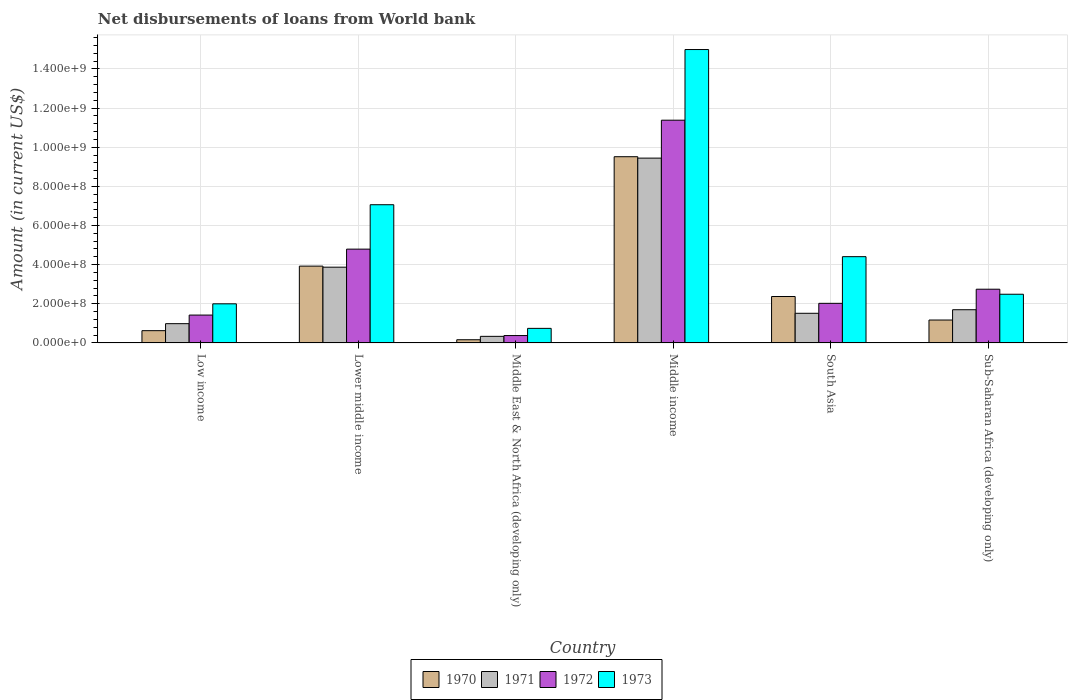How many different coloured bars are there?
Your answer should be very brief. 4. How many bars are there on the 1st tick from the left?
Ensure brevity in your answer.  4. How many bars are there on the 4th tick from the right?
Make the answer very short. 4. In how many cases, is the number of bars for a given country not equal to the number of legend labels?
Provide a short and direct response. 0. What is the amount of loan disbursed from World Bank in 1971 in Middle East & North Africa (developing only)?
Your answer should be very brief. 3.37e+07. Across all countries, what is the maximum amount of loan disbursed from World Bank in 1971?
Your answer should be very brief. 9.44e+08. Across all countries, what is the minimum amount of loan disbursed from World Bank in 1970?
Offer a terse response. 1.64e+07. In which country was the amount of loan disbursed from World Bank in 1970 minimum?
Your answer should be compact. Middle East & North Africa (developing only). What is the total amount of loan disbursed from World Bank in 1972 in the graph?
Provide a succinct answer. 2.27e+09. What is the difference between the amount of loan disbursed from World Bank in 1971 in Middle East & North Africa (developing only) and that in Sub-Saharan Africa (developing only)?
Your answer should be compact. -1.36e+08. What is the difference between the amount of loan disbursed from World Bank in 1970 in Lower middle income and the amount of loan disbursed from World Bank in 1971 in Middle income?
Keep it short and to the point. -5.52e+08. What is the average amount of loan disbursed from World Bank in 1973 per country?
Provide a succinct answer. 5.28e+08. What is the difference between the amount of loan disbursed from World Bank of/in 1970 and amount of loan disbursed from World Bank of/in 1972 in Sub-Saharan Africa (developing only)?
Provide a short and direct response. -1.57e+08. What is the ratio of the amount of loan disbursed from World Bank in 1971 in Low income to that in Middle East & North Africa (developing only)?
Ensure brevity in your answer.  2.92. Is the amount of loan disbursed from World Bank in 1973 in Lower middle income less than that in South Asia?
Your answer should be very brief. No. What is the difference between the highest and the second highest amount of loan disbursed from World Bank in 1972?
Provide a short and direct response. 8.63e+08. What is the difference between the highest and the lowest amount of loan disbursed from World Bank in 1971?
Make the answer very short. 9.10e+08. In how many countries, is the amount of loan disbursed from World Bank in 1971 greater than the average amount of loan disbursed from World Bank in 1971 taken over all countries?
Offer a terse response. 2. Is the sum of the amount of loan disbursed from World Bank in 1970 in Lower middle income and South Asia greater than the maximum amount of loan disbursed from World Bank in 1972 across all countries?
Your response must be concise. No. Is it the case that in every country, the sum of the amount of loan disbursed from World Bank in 1972 and amount of loan disbursed from World Bank in 1971 is greater than the amount of loan disbursed from World Bank in 1973?
Provide a short and direct response. No. Are all the bars in the graph horizontal?
Your response must be concise. No. What is the difference between two consecutive major ticks on the Y-axis?
Your response must be concise. 2.00e+08. Are the values on the major ticks of Y-axis written in scientific E-notation?
Make the answer very short. Yes. How many legend labels are there?
Your response must be concise. 4. What is the title of the graph?
Ensure brevity in your answer.  Net disbursements of loans from World bank. What is the label or title of the X-axis?
Your answer should be compact. Country. What is the Amount (in current US$) in 1970 in Low income?
Offer a terse response. 6.27e+07. What is the Amount (in current US$) of 1971 in Low income?
Offer a terse response. 9.85e+07. What is the Amount (in current US$) of 1972 in Low income?
Provide a succinct answer. 1.42e+08. What is the Amount (in current US$) of 1973 in Low income?
Keep it short and to the point. 2.00e+08. What is the Amount (in current US$) of 1970 in Lower middle income?
Ensure brevity in your answer.  3.92e+08. What is the Amount (in current US$) of 1971 in Lower middle income?
Provide a succinct answer. 3.87e+08. What is the Amount (in current US$) in 1972 in Lower middle income?
Your answer should be compact. 4.79e+08. What is the Amount (in current US$) in 1973 in Lower middle income?
Give a very brief answer. 7.06e+08. What is the Amount (in current US$) of 1970 in Middle East & North Africa (developing only)?
Provide a short and direct response. 1.64e+07. What is the Amount (in current US$) in 1971 in Middle East & North Africa (developing only)?
Provide a short and direct response. 3.37e+07. What is the Amount (in current US$) in 1972 in Middle East & North Africa (developing only)?
Offer a terse response. 3.77e+07. What is the Amount (in current US$) of 1973 in Middle East & North Africa (developing only)?
Keep it short and to the point. 7.45e+07. What is the Amount (in current US$) of 1970 in Middle income?
Your answer should be compact. 9.51e+08. What is the Amount (in current US$) in 1971 in Middle income?
Ensure brevity in your answer.  9.44e+08. What is the Amount (in current US$) in 1972 in Middle income?
Provide a succinct answer. 1.14e+09. What is the Amount (in current US$) in 1973 in Middle income?
Your answer should be compact. 1.50e+09. What is the Amount (in current US$) of 1970 in South Asia?
Your answer should be compact. 2.37e+08. What is the Amount (in current US$) of 1971 in South Asia?
Ensure brevity in your answer.  1.51e+08. What is the Amount (in current US$) in 1972 in South Asia?
Give a very brief answer. 2.02e+08. What is the Amount (in current US$) in 1973 in South Asia?
Make the answer very short. 4.41e+08. What is the Amount (in current US$) of 1970 in Sub-Saharan Africa (developing only)?
Make the answer very short. 1.17e+08. What is the Amount (in current US$) of 1971 in Sub-Saharan Africa (developing only)?
Provide a succinct answer. 1.70e+08. What is the Amount (in current US$) of 1972 in Sub-Saharan Africa (developing only)?
Offer a very short reply. 2.74e+08. What is the Amount (in current US$) in 1973 in Sub-Saharan Africa (developing only)?
Keep it short and to the point. 2.49e+08. Across all countries, what is the maximum Amount (in current US$) of 1970?
Your answer should be compact. 9.51e+08. Across all countries, what is the maximum Amount (in current US$) of 1971?
Keep it short and to the point. 9.44e+08. Across all countries, what is the maximum Amount (in current US$) in 1972?
Keep it short and to the point. 1.14e+09. Across all countries, what is the maximum Amount (in current US$) in 1973?
Keep it short and to the point. 1.50e+09. Across all countries, what is the minimum Amount (in current US$) in 1970?
Give a very brief answer. 1.64e+07. Across all countries, what is the minimum Amount (in current US$) in 1971?
Provide a succinct answer. 3.37e+07. Across all countries, what is the minimum Amount (in current US$) of 1972?
Offer a terse response. 3.77e+07. Across all countries, what is the minimum Amount (in current US$) in 1973?
Offer a very short reply. 7.45e+07. What is the total Amount (in current US$) of 1970 in the graph?
Give a very brief answer. 1.78e+09. What is the total Amount (in current US$) in 1971 in the graph?
Provide a short and direct response. 1.78e+09. What is the total Amount (in current US$) in 1972 in the graph?
Keep it short and to the point. 2.27e+09. What is the total Amount (in current US$) of 1973 in the graph?
Keep it short and to the point. 3.17e+09. What is the difference between the Amount (in current US$) in 1970 in Low income and that in Lower middle income?
Offer a terse response. -3.30e+08. What is the difference between the Amount (in current US$) in 1971 in Low income and that in Lower middle income?
Your answer should be very brief. -2.89e+08. What is the difference between the Amount (in current US$) in 1972 in Low income and that in Lower middle income?
Ensure brevity in your answer.  -3.37e+08. What is the difference between the Amount (in current US$) in 1973 in Low income and that in Lower middle income?
Offer a very short reply. -5.06e+08. What is the difference between the Amount (in current US$) of 1970 in Low income and that in Middle East & North Africa (developing only)?
Your answer should be very brief. 4.63e+07. What is the difference between the Amount (in current US$) of 1971 in Low income and that in Middle East & North Africa (developing only)?
Offer a terse response. 6.48e+07. What is the difference between the Amount (in current US$) in 1972 in Low income and that in Middle East & North Africa (developing only)?
Offer a very short reply. 1.05e+08. What is the difference between the Amount (in current US$) of 1973 in Low income and that in Middle East & North Africa (developing only)?
Your answer should be very brief. 1.25e+08. What is the difference between the Amount (in current US$) of 1970 in Low income and that in Middle income?
Your answer should be very brief. -8.89e+08. What is the difference between the Amount (in current US$) of 1971 in Low income and that in Middle income?
Ensure brevity in your answer.  -8.46e+08. What is the difference between the Amount (in current US$) of 1972 in Low income and that in Middle income?
Your answer should be compact. -9.96e+08. What is the difference between the Amount (in current US$) of 1973 in Low income and that in Middle income?
Provide a succinct answer. -1.30e+09. What is the difference between the Amount (in current US$) in 1970 in Low income and that in South Asia?
Give a very brief answer. -1.74e+08. What is the difference between the Amount (in current US$) of 1971 in Low income and that in South Asia?
Your answer should be compact. -5.29e+07. What is the difference between the Amount (in current US$) in 1972 in Low income and that in South Asia?
Offer a very short reply. -5.99e+07. What is the difference between the Amount (in current US$) in 1973 in Low income and that in South Asia?
Your answer should be very brief. -2.41e+08. What is the difference between the Amount (in current US$) of 1970 in Low income and that in Sub-Saharan Africa (developing only)?
Offer a terse response. -5.43e+07. What is the difference between the Amount (in current US$) of 1971 in Low income and that in Sub-Saharan Africa (developing only)?
Give a very brief answer. -7.12e+07. What is the difference between the Amount (in current US$) in 1972 in Low income and that in Sub-Saharan Africa (developing only)?
Give a very brief answer. -1.32e+08. What is the difference between the Amount (in current US$) in 1973 in Low income and that in Sub-Saharan Africa (developing only)?
Your answer should be very brief. -4.89e+07. What is the difference between the Amount (in current US$) of 1970 in Lower middle income and that in Middle East & North Africa (developing only)?
Provide a short and direct response. 3.76e+08. What is the difference between the Amount (in current US$) of 1971 in Lower middle income and that in Middle East & North Africa (developing only)?
Offer a very short reply. 3.53e+08. What is the difference between the Amount (in current US$) in 1972 in Lower middle income and that in Middle East & North Africa (developing only)?
Ensure brevity in your answer.  4.41e+08. What is the difference between the Amount (in current US$) in 1973 in Lower middle income and that in Middle East & North Africa (developing only)?
Make the answer very short. 6.32e+08. What is the difference between the Amount (in current US$) in 1970 in Lower middle income and that in Middle income?
Your answer should be very brief. -5.59e+08. What is the difference between the Amount (in current US$) of 1971 in Lower middle income and that in Middle income?
Your answer should be very brief. -5.57e+08. What is the difference between the Amount (in current US$) of 1972 in Lower middle income and that in Middle income?
Offer a terse response. -6.59e+08. What is the difference between the Amount (in current US$) in 1973 in Lower middle income and that in Middle income?
Give a very brief answer. -7.93e+08. What is the difference between the Amount (in current US$) in 1970 in Lower middle income and that in South Asia?
Your answer should be compact. 1.55e+08. What is the difference between the Amount (in current US$) of 1971 in Lower middle income and that in South Asia?
Your answer should be very brief. 2.36e+08. What is the difference between the Amount (in current US$) in 1972 in Lower middle income and that in South Asia?
Ensure brevity in your answer.  2.77e+08. What is the difference between the Amount (in current US$) in 1973 in Lower middle income and that in South Asia?
Make the answer very short. 2.65e+08. What is the difference between the Amount (in current US$) of 1970 in Lower middle income and that in Sub-Saharan Africa (developing only)?
Your answer should be compact. 2.75e+08. What is the difference between the Amount (in current US$) of 1971 in Lower middle income and that in Sub-Saharan Africa (developing only)?
Your answer should be very brief. 2.17e+08. What is the difference between the Amount (in current US$) in 1972 in Lower middle income and that in Sub-Saharan Africa (developing only)?
Provide a succinct answer. 2.05e+08. What is the difference between the Amount (in current US$) of 1973 in Lower middle income and that in Sub-Saharan Africa (developing only)?
Your response must be concise. 4.57e+08. What is the difference between the Amount (in current US$) of 1970 in Middle East & North Africa (developing only) and that in Middle income?
Offer a terse response. -9.35e+08. What is the difference between the Amount (in current US$) in 1971 in Middle East & North Africa (developing only) and that in Middle income?
Ensure brevity in your answer.  -9.10e+08. What is the difference between the Amount (in current US$) of 1972 in Middle East & North Africa (developing only) and that in Middle income?
Make the answer very short. -1.10e+09. What is the difference between the Amount (in current US$) in 1973 in Middle East & North Africa (developing only) and that in Middle income?
Your response must be concise. -1.42e+09. What is the difference between the Amount (in current US$) of 1970 in Middle East & North Africa (developing only) and that in South Asia?
Your answer should be compact. -2.21e+08. What is the difference between the Amount (in current US$) in 1971 in Middle East & North Africa (developing only) and that in South Asia?
Give a very brief answer. -1.18e+08. What is the difference between the Amount (in current US$) of 1972 in Middle East & North Africa (developing only) and that in South Asia?
Provide a short and direct response. -1.65e+08. What is the difference between the Amount (in current US$) of 1973 in Middle East & North Africa (developing only) and that in South Asia?
Offer a terse response. -3.66e+08. What is the difference between the Amount (in current US$) of 1970 in Middle East & North Africa (developing only) and that in Sub-Saharan Africa (developing only)?
Offer a very short reply. -1.01e+08. What is the difference between the Amount (in current US$) in 1971 in Middle East & North Africa (developing only) and that in Sub-Saharan Africa (developing only)?
Provide a succinct answer. -1.36e+08. What is the difference between the Amount (in current US$) in 1972 in Middle East & North Africa (developing only) and that in Sub-Saharan Africa (developing only)?
Offer a very short reply. -2.37e+08. What is the difference between the Amount (in current US$) of 1973 in Middle East & North Africa (developing only) and that in Sub-Saharan Africa (developing only)?
Provide a succinct answer. -1.74e+08. What is the difference between the Amount (in current US$) in 1970 in Middle income and that in South Asia?
Your answer should be very brief. 7.14e+08. What is the difference between the Amount (in current US$) in 1971 in Middle income and that in South Asia?
Offer a very short reply. 7.93e+08. What is the difference between the Amount (in current US$) of 1972 in Middle income and that in South Asia?
Provide a succinct answer. 9.36e+08. What is the difference between the Amount (in current US$) of 1973 in Middle income and that in South Asia?
Your answer should be very brief. 1.06e+09. What is the difference between the Amount (in current US$) in 1970 in Middle income and that in Sub-Saharan Africa (developing only)?
Offer a very short reply. 8.34e+08. What is the difference between the Amount (in current US$) in 1971 in Middle income and that in Sub-Saharan Africa (developing only)?
Offer a very short reply. 7.74e+08. What is the difference between the Amount (in current US$) in 1972 in Middle income and that in Sub-Saharan Africa (developing only)?
Ensure brevity in your answer.  8.63e+08. What is the difference between the Amount (in current US$) in 1973 in Middle income and that in Sub-Saharan Africa (developing only)?
Your response must be concise. 1.25e+09. What is the difference between the Amount (in current US$) in 1970 in South Asia and that in Sub-Saharan Africa (developing only)?
Offer a terse response. 1.20e+08. What is the difference between the Amount (in current US$) in 1971 in South Asia and that in Sub-Saharan Africa (developing only)?
Your response must be concise. -1.83e+07. What is the difference between the Amount (in current US$) of 1972 in South Asia and that in Sub-Saharan Africa (developing only)?
Offer a terse response. -7.21e+07. What is the difference between the Amount (in current US$) of 1973 in South Asia and that in Sub-Saharan Africa (developing only)?
Your answer should be very brief. 1.92e+08. What is the difference between the Amount (in current US$) of 1970 in Low income and the Amount (in current US$) of 1971 in Lower middle income?
Your answer should be very brief. -3.24e+08. What is the difference between the Amount (in current US$) in 1970 in Low income and the Amount (in current US$) in 1972 in Lower middle income?
Make the answer very short. -4.17e+08. What is the difference between the Amount (in current US$) in 1970 in Low income and the Amount (in current US$) in 1973 in Lower middle income?
Provide a succinct answer. -6.43e+08. What is the difference between the Amount (in current US$) in 1971 in Low income and the Amount (in current US$) in 1972 in Lower middle income?
Make the answer very short. -3.81e+08. What is the difference between the Amount (in current US$) in 1971 in Low income and the Amount (in current US$) in 1973 in Lower middle income?
Provide a short and direct response. -6.08e+08. What is the difference between the Amount (in current US$) in 1972 in Low income and the Amount (in current US$) in 1973 in Lower middle income?
Your response must be concise. -5.64e+08. What is the difference between the Amount (in current US$) of 1970 in Low income and the Amount (in current US$) of 1971 in Middle East & North Africa (developing only)?
Make the answer very short. 2.90e+07. What is the difference between the Amount (in current US$) of 1970 in Low income and the Amount (in current US$) of 1972 in Middle East & North Africa (developing only)?
Your response must be concise. 2.50e+07. What is the difference between the Amount (in current US$) of 1970 in Low income and the Amount (in current US$) of 1973 in Middle East & North Africa (developing only)?
Your answer should be compact. -1.18e+07. What is the difference between the Amount (in current US$) in 1971 in Low income and the Amount (in current US$) in 1972 in Middle East & North Africa (developing only)?
Provide a succinct answer. 6.08e+07. What is the difference between the Amount (in current US$) of 1971 in Low income and the Amount (in current US$) of 1973 in Middle East & North Africa (developing only)?
Offer a very short reply. 2.40e+07. What is the difference between the Amount (in current US$) in 1972 in Low income and the Amount (in current US$) in 1973 in Middle East & North Africa (developing only)?
Provide a short and direct response. 6.79e+07. What is the difference between the Amount (in current US$) in 1970 in Low income and the Amount (in current US$) in 1971 in Middle income?
Provide a succinct answer. -8.81e+08. What is the difference between the Amount (in current US$) of 1970 in Low income and the Amount (in current US$) of 1972 in Middle income?
Give a very brief answer. -1.08e+09. What is the difference between the Amount (in current US$) of 1970 in Low income and the Amount (in current US$) of 1973 in Middle income?
Your response must be concise. -1.44e+09. What is the difference between the Amount (in current US$) of 1971 in Low income and the Amount (in current US$) of 1972 in Middle income?
Provide a short and direct response. -1.04e+09. What is the difference between the Amount (in current US$) in 1971 in Low income and the Amount (in current US$) in 1973 in Middle income?
Provide a short and direct response. -1.40e+09. What is the difference between the Amount (in current US$) of 1972 in Low income and the Amount (in current US$) of 1973 in Middle income?
Provide a succinct answer. -1.36e+09. What is the difference between the Amount (in current US$) of 1970 in Low income and the Amount (in current US$) of 1971 in South Asia?
Ensure brevity in your answer.  -8.87e+07. What is the difference between the Amount (in current US$) of 1970 in Low income and the Amount (in current US$) of 1972 in South Asia?
Your response must be concise. -1.40e+08. What is the difference between the Amount (in current US$) in 1970 in Low income and the Amount (in current US$) in 1973 in South Asia?
Make the answer very short. -3.78e+08. What is the difference between the Amount (in current US$) in 1971 in Low income and the Amount (in current US$) in 1972 in South Asia?
Your answer should be very brief. -1.04e+08. What is the difference between the Amount (in current US$) in 1971 in Low income and the Amount (in current US$) in 1973 in South Asia?
Provide a succinct answer. -3.42e+08. What is the difference between the Amount (in current US$) of 1972 in Low income and the Amount (in current US$) of 1973 in South Asia?
Provide a short and direct response. -2.98e+08. What is the difference between the Amount (in current US$) in 1970 in Low income and the Amount (in current US$) in 1971 in Sub-Saharan Africa (developing only)?
Ensure brevity in your answer.  -1.07e+08. What is the difference between the Amount (in current US$) in 1970 in Low income and the Amount (in current US$) in 1972 in Sub-Saharan Africa (developing only)?
Offer a terse response. -2.12e+08. What is the difference between the Amount (in current US$) of 1970 in Low income and the Amount (in current US$) of 1973 in Sub-Saharan Africa (developing only)?
Your answer should be compact. -1.86e+08. What is the difference between the Amount (in current US$) in 1971 in Low income and the Amount (in current US$) in 1972 in Sub-Saharan Africa (developing only)?
Give a very brief answer. -1.76e+08. What is the difference between the Amount (in current US$) of 1971 in Low income and the Amount (in current US$) of 1973 in Sub-Saharan Africa (developing only)?
Your answer should be very brief. -1.50e+08. What is the difference between the Amount (in current US$) of 1972 in Low income and the Amount (in current US$) of 1973 in Sub-Saharan Africa (developing only)?
Give a very brief answer. -1.06e+08. What is the difference between the Amount (in current US$) in 1970 in Lower middle income and the Amount (in current US$) in 1971 in Middle East & North Africa (developing only)?
Provide a short and direct response. 3.59e+08. What is the difference between the Amount (in current US$) in 1970 in Lower middle income and the Amount (in current US$) in 1972 in Middle East & North Africa (developing only)?
Keep it short and to the point. 3.55e+08. What is the difference between the Amount (in current US$) of 1970 in Lower middle income and the Amount (in current US$) of 1973 in Middle East & North Africa (developing only)?
Give a very brief answer. 3.18e+08. What is the difference between the Amount (in current US$) in 1971 in Lower middle income and the Amount (in current US$) in 1972 in Middle East & North Africa (developing only)?
Give a very brief answer. 3.49e+08. What is the difference between the Amount (in current US$) of 1971 in Lower middle income and the Amount (in current US$) of 1973 in Middle East & North Africa (developing only)?
Make the answer very short. 3.13e+08. What is the difference between the Amount (in current US$) in 1972 in Lower middle income and the Amount (in current US$) in 1973 in Middle East & North Africa (developing only)?
Your response must be concise. 4.05e+08. What is the difference between the Amount (in current US$) of 1970 in Lower middle income and the Amount (in current US$) of 1971 in Middle income?
Your answer should be very brief. -5.52e+08. What is the difference between the Amount (in current US$) in 1970 in Lower middle income and the Amount (in current US$) in 1972 in Middle income?
Your answer should be compact. -7.46e+08. What is the difference between the Amount (in current US$) of 1970 in Lower middle income and the Amount (in current US$) of 1973 in Middle income?
Your answer should be compact. -1.11e+09. What is the difference between the Amount (in current US$) of 1971 in Lower middle income and the Amount (in current US$) of 1972 in Middle income?
Keep it short and to the point. -7.51e+08. What is the difference between the Amount (in current US$) in 1971 in Lower middle income and the Amount (in current US$) in 1973 in Middle income?
Offer a very short reply. -1.11e+09. What is the difference between the Amount (in current US$) of 1972 in Lower middle income and the Amount (in current US$) of 1973 in Middle income?
Keep it short and to the point. -1.02e+09. What is the difference between the Amount (in current US$) in 1970 in Lower middle income and the Amount (in current US$) in 1971 in South Asia?
Provide a short and direct response. 2.41e+08. What is the difference between the Amount (in current US$) of 1970 in Lower middle income and the Amount (in current US$) of 1972 in South Asia?
Provide a short and direct response. 1.90e+08. What is the difference between the Amount (in current US$) of 1970 in Lower middle income and the Amount (in current US$) of 1973 in South Asia?
Your response must be concise. -4.83e+07. What is the difference between the Amount (in current US$) of 1971 in Lower middle income and the Amount (in current US$) of 1972 in South Asia?
Offer a very short reply. 1.85e+08. What is the difference between the Amount (in current US$) in 1971 in Lower middle income and the Amount (in current US$) in 1973 in South Asia?
Provide a succinct answer. -5.37e+07. What is the difference between the Amount (in current US$) in 1972 in Lower middle income and the Amount (in current US$) in 1973 in South Asia?
Provide a short and direct response. 3.85e+07. What is the difference between the Amount (in current US$) of 1970 in Lower middle income and the Amount (in current US$) of 1971 in Sub-Saharan Africa (developing only)?
Your answer should be very brief. 2.23e+08. What is the difference between the Amount (in current US$) of 1970 in Lower middle income and the Amount (in current US$) of 1972 in Sub-Saharan Africa (developing only)?
Ensure brevity in your answer.  1.18e+08. What is the difference between the Amount (in current US$) of 1970 in Lower middle income and the Amount (in current US$) of 1973 in Sub-Saharan Africa (developing only)?
Ensure brevity in your answer.  1.44e+08. What is the difference between the Amount (in current US$) of 1971 in Lower middle income and the Amount (in current US$) of 1972 in Sub-Saharan Africa (developing only)?
Your answer should be very brief. 1.13e+08. What is the difference between the Amount (in current US$) of 1971 in Lower middle income and the Amount (in current US$) of 1973 in Sub-Saharan Africa (developing only)?
Offer a very short reply. 1.38e+08. What is the difference between the Amount (in current US$) in 1972 in Lower middle income and the Amount (in current US$) in 1973 in Sub-Saharan Africa (developing only)?
Your answer should be compact. 2.30e+08. What is the difference between the Amount (in current US$) of 1970 in Middle East & North Africa (developing only) and the Amount (in current US$) of 1971 in Middle income?
Offer a terse response. -9.28e+08. What is the difference between the Amount (in current US$) of 1970 in Middle East & North Africa (developing only) and the Amount (in current US$) of 1972 in Middle income?
Offer a terse response. -1.12e+09. What is the difference between the Amount (in current US$) of 1970 in Middle East & North Africa (developing only) and the Amount (in current US$) of 1973 in Middle income?
Your answer should be compact. -1.48e+09. What is the difference between the Amount (in current US$) in 1971 in Middle East & North Africa (developing only) and the Amount (in current US$) in 1972 in Middle income?
Ensure brevity in your answer.  -1.10e+09. What is the difference between the Amount (in current US$) in 1971 in Middle East & North Africa (developing only) and the Amount (in current US$) in 1973 in Middle income?
Offer a very short reply. -1.47e+09. What is the difference between the Amount (in current US$) of 1972 in Middle East & North Africa (developing only) and the Amount (in current US$) of 1973 in Middle income?
Ensure brevity in your answer.  -1.46e+09. What is the difference between the Amount (in current US$) in 1970 in Middle East & North Africa (developing only) and the Amount (in current US$) in 1971 in South Asia?
Make the answer very short. -1.35e+08. What is the difference between the Amount (in current US$) in 1970 in Middle East & North Africa (developing only) and the Amount (in current US$) in 1972 in South Asia?
Give a very brief answer. -1.86e+08. What is the difference between the Amount (in current US$) in 1970 in Middle East & North Africa (developing only) and the Amount (in current US$) in 1973 in South Asia?
Your response must be concise. -4.24e+08. What is the difference between the Amount (in current US$) of 1971 in Middle East & North Africa (developing only) and the Amount (in current US$) of 1972 in South Asia?
Ensure brevity in your answer.  -1.69e+08. What is the difference between the Amount (in current US$) of 1971 in Middle East & North Africa (developing only) and the Amount (in current US$) of 1973 in South Asia?
Offer a very short reply. -4.07e+08. What is the difference between the Amount (in current US$) of 1972 in Middle East & North Africa (developing only) and the Amount (in current US$) of 1973 in South Asia?
Keep it short and to the point. -4.03e+08. What is the difference between the Amount (in current US$) in 1970 in Middle East & North Africa (developing only) and the Amount (in current US$) in 1971 in Sub-Saharan Africa (developing only)?
Offer a terse response. -1.53e+08. What is the difference between the Amount (in current US$) in 1970 in Middle East & North Africa (developing only) and the Amount (in current US$) in 1972 in Sub-Saharan Africa (developing only)?
Keep it short and to the point. -2.58e+08. What is the difference between the Amount (in current US$) of 1970 in Middle East & North Africa (developing only) and the Amount (in current US$) of 1973 in Sub-Saharan Africa (developing only)?
Make the answer very short. -2.32e+08. What is the difference between the Amount (in current US$) in 1971 in Middle East & North Africa (developing only) and the Amount (in current US$) in 1972 in Sub-Saharan Africa (developing only)?
Offer a very short reply. -2.41e+08. What is the difference between the Amount (in current US$) of 1971 in Middle East & North Africa (developing only) and the Amount (in current US$) of 1973 in Sub-Saharan Africa (developing only)?
Provide a succinct answer. -2.15e+08. What is the difference between the Amount (in current US$) of 1972 in Middle East & North Africa (developing only) and the Amount (in current US$) of 1973 in Sub-Saharan Africa (developing only)?
Ensure brevity in your answer.  -2.11e+08. What is the difference between the Amount (in current US$) in 1970 in Middle income and the Amount (in current US$) in 1971 in South Asia?
Offer a very short reply. 8.00e+08. What is the difference between the Amount (in current US$) of 1970 in Middle income and the Amount (in current US$) of 1972 in South Asia?
Your response must be concise. 7.49e+08. What is the difference between the Amount (in current US$) of 1970 in Middle income and the Amount (in current US$) of 1973 in South Asia?
Give a very brief answer. 5.11e+08. What is the difference between the Amount (in current US$) in 1971 in Middle income and the Amount (in current US$) in 1972 in South Asia?
Your answer should be compact. 7.42e+08. What is the difference between the Amount (in current US$) in 1971 in Middle income and the Amount (in current US$) in 1973 in South Asia?
Provide a short and direct response. 5.03e+08. What is the difference between the Amount (in current US$) in 1972 in Middle income and the Amount (in current US$) in 1973 in South Asia?
Your answer should be compact. 6.97e+08. What is the difference between the Amount (in current US$) in 1970 in Middle income and the Amount (in current US$) in 1971 in Sub-Saharan Africa (developing only)?
Give a very brief answer. 7.82e+08. What is the difference between the Amount (in current US$) of 1970 in Middle income and the Amount (in current US$) of 1972 in Sub-Saharan Africa (developing only)?
Your response must be concise. 6.77e+08. What is the difference between the Amount (in current US$) of 1970 in Middle income and the Amount (in current US$) of 1973 in Sub-Saharan Africa (developing only)?
Your response must be concise. 7.03e+08. What is the difference between the Amount (in current US$) of 1971 in Middle income and the Amount (in current US$) of 1972 in Sub-Saharan Africa (developing only)?
Your response must be concise. 6.70e+08. What is the difference between the Amount (in current US$) of 1971 in Middle income and the Amount (in current US$) of 1973 in Sub-Saharan Africa (developing only)?
Ensure brevity in your answer.  6.95e+08. What is the difference between the Amount (in current US$) of 1972 in Middle income and the Amount (in current US$) of 1973 in Sub-Saharan Africa (developing only)?
Provide a short and direct response. 8.89e+08. What is the difference between the Amount (in current US$) in 1970 in South Asia and the Amount (in current US$) in 1971 in Sub-Saharan Africa (developing only)?
Give a very brief answer. 6.75e+07. What is the difference between the Amount (in current US$) of 1970 in South Asia and the Amount (in current US$) of 1972 in Sub-Saharan Africa (developing only)?
Provide a succinct answer. -3.73e+07. What is the difference between the Amount (in current US$) in 1970 in South Asia and the Amount (in current US$) in 1973 in Sub-Saharan Africa (developing only)?
Provide a succinct answer. -1.16e+07. What is the difference between the Amount (in current US$) of 1971 in South Asia and the Amount (in current US$) of 1972 in Sub-Saharan Africa (developing only)?
Give a very brief answer. -1.23e+08. What is the difference between the Amount (in current US$) in 1971 in South Asia and the Amount (in current US$) in 1973 in Sub-Saharan Africa (developing only)?
Provide a short and direct response. -9.74e+07. What is the difference between the Amount (in current US$) of 1972 in South Asia and the Amount (in current US$) of 1973 in Sub-Saharan Africa (developing only)?
Your answer should be compact. -4.65e+07. What is the average Amount (in current US$) in 1970 per country?
Offer a terse response. 2.96e+08. What is the average Amount (in current US$) in 1971 per country?
Provide a succinct answer. 2.97e+08. What is the average Amount (in current US$) of 1972 per country?
Provide a succinct answer. 3.79e+08. What is the average Amount (in current US$) of 1973 per country?
Provide a succinct answer. 5.28e+08. What is the difference between the Amount (in current US$) of 1970 and Amount (in current US$) of 1971 in Low income?
Offer a terse response. -3.58e+07. What is the difference between the Amount (in current US$) of 1970 and Amount (in current US$) of 1972 in Low income?
Offer a very short reply. -7.97e+07. What is the difference between the Amount (in current US$) in 1970 and Amount (in current US$) in 1973 in Low income?
Give a very brief answer. -1.37e+08. What is the difference between the Amount (in current US$) in 1971 and Amount (in current US$) in 1972 in Low income?
Your answer should be very brief. -4.39e+07. What is the difference between the Amount (in current US$) of 1971 and Amount (in current US$) of 1973 in Low income?
Your response must be concise. -1.01e+08. What is the difference between the Amount (in current US$) in 1972 and Amount (in current US$) in 1973 in Low income?
Provide a short and direct response. -5.75e+07. What is the difference between the Amount (in current US$) in 1970 and Amount (in current US$) in 1971 in Lower middle income?
Your answer should be compact. 5.37e+06. What is the difference between the Amount (in current US$) of 1970 and Amount (in current US$) of 1972 in Lower middle income?
Provide a short and direct response. -8.68e+07. What is the difference between the Amount (in current US$) of 1970 and Amount (in current US$) of 1973 in Lower middle income?
Give a very brief answer. -3.14e+08. What is the difference between the Amount (in current US$) of 1971 and Amount (in current US$) of 1972 in Lower middle income?
Give a very brief answer. -9.22e+07. What is the difference between the Amount (in current US$) of 1971 and Amount (in current US$) of 1973 in Lower middle income?
Give a very brief answer. -3.19e+08. What is the difference between the Amount (in current US$) in 1972 and Amount (in current US$) in 1973 in Lower middle income?
Offer a very short reply. -2.27e+08. What is the difference between the Amount (in current US$) in 1970 and Amount (in current US$) in 1971 in Middle East & North Africa (developing only)?
Offer a terse response. -1.73e+07. What is the difference between the Amount (in current US$) of 1970 and Amount (in current US$) of 1972 in Middle East & North Africa (developing only)?
Ensure brevity in your answer.  -2.14e+07. What is the difference between the Amount (in current US$) in 1970 and Amount (in current US$) in 1973 in Middle East & North Africa (developing only)?
Provide a succinct answer. -5.81e+07. What is the difference between the Amount (in current US$) in 1971 and Amount (in current US$) in 1972 in Middle East & North Africa (developing only)?
Give a very brief answer. -4.06e+06. What is the difference between the Amount (in current US$) of 1971 and Amount (in current US$) of 1973 in Middle East & North Africa (developing only)?
Keep it short and to the point. -4.08e+07. What is the difference between the Amount (in current US$) in 1972 and Amount (in current US$) in 1973 in Middle East & North Africa (developing only)?
Your answer should be very brief. -3.67e+07. What is the difference between the Amount (in current US$) in 1970 and Amount (in current US$) in 1971 in Middle income?
Offer a very short reply. 7.21e+06. What is the difference between the Amount (in current US$) of 1970 and Amount (in current US$) of 1972 in Middle income?
Provide a succinct answer. -1.87e+08. What is the difference between the Amount (in current US$) in 1970 and Amount (in current US$) in 1973 in Middle income?
Make the answer very short. -5.47e+08. What is the difference between the Amount (in current US$) of 1971 and Amount (in current US$) of 1972 in Middle income?
Give a very brief answer. -1.94e+08. What is the difference between the Amount (in current US$) of 1971 and Amount (in current US$) of 1973 in Middle income?
Ensure brevity in your answer.  -5.55e+08. What is the difference between the Amount (in current US$) of 1972 and Amount (in current US$) of 1973 in Middle income?
Provide a succinct answer. -3.61e+08. What is the difference between the Amount (in current US$) in 1970 and Amount (in current US$) in 1971 in South Asia?
Your answer should be compact. 8.58e+07. What is the difference between the Amount (in current US$) of 1970 and Amount (in current US$) of 1972 in South Asia?
Make the answer very short. 3.49e+07. What is the difference between the Amount (in current US$) of 1970 and Amount (in current US$) of 1973 in South Asia?
Offer a terse response. -2.04e+08. What is the difference between the Amount (in current US$) of 1971 and Amount (in current US$) of 1972 in South Asia?
Offer a very short reply. -5.09e+07. What is the difference between the Amount (in current US$) of 1971 and Amount (in current US$) of 1973 in South Asia?
Give a very brief answer. -2.89e+08. What is the difference between the Amount (in current US$) of 1972 and Amount (in current US$) of 1973 in South Asia?
Provide a short and direct response. -2.38e+08. What is the difference between the Amount (in current US$) in 1970 and Amount (in current US$) in 1971 in Sub-Saharan Africa (developing only)?
Provide a succinct answer. -5.27e+07. What is the difference between the Amount (in current US$) in 1970 and Amount (in current US$) in 1972 in Sub-Saharan Africa (developing only)?
Keep it short and to the point. -1.57e+08. What is the difference between the Amount (in current US$) of 1970 and Amount (in current US$) of 1973 in Sub-Saharan Africa (developing only)?
Give a very brief answer. -1.32e+08. What is the difference between the Amount (in current US$) in 1971 and Amount (in current US$) in 1972 in Sub-Saharan Africa (developing only)?
Give a very brief answer. -1.05e+08. What is the difference between the Amount (in current US$) of 1971 and Amount (in current US$) of 1973 in Sub-Saharan Africa (developing only)?
Give a very brief answer. -7.91e+07. What is the difference between the Amount (in current US$) of 1972 and Amount (in current US$) of 1973 in Sub-Saharan Africa (developing only)?
Ensure brevity in your answer.  2.57e+07. What is the ratio of the Amount (in current US$) in 1970 in Low income to that in Lower middle income?
Your answer should be compact. 0.16. What is the ratio of the Amount (in current US$) in 1971 in Low income to that in Lower middle income?
Provide a short and direct response. 0.25. What is the ratio of the Amount (in current US$) in 1972 in Low income to that in Lower middle income?
Ensure brevity in your answer.  0.3. What is the ratio of the Amount (in current US$) of 1973 in Low income to that in Lower middle income?
Your answer should be compact. 0.28. What is the ratio of the Amount (in current US$) in 1970 in Low income to that in Middle East & North Africa (developing only)?
Offer a terse response. 3.83. What is the ratio of the Amount (in current US$) of 1971 in Low income to that in Middle East & North Africa (developing only)?
Offer a terse response. 2.92. What is the ratio of the Amount (in current US$) in 1972 in Low income to that in Middle East & North Africa (developing only)?
Ensure brevity in your answer.  3.77. What is the ratio of the Amount (in current US$) of 1973 in Low income to that in Middle East & North Africa (developing only)?
Offer a terse response. 2.68. What is the ratio of the Amount (in current US$) of 1970 in Low income to that in Middle income?
Offer a terse response. 0.07. What is the ratio of the Amount (in current US$) in 1971 in Low income to that in Middle income?
Provide a succinct answer. 0.1. What is the ratio of the Amount (in current US$) of 1972 in Low income to that in Middle income?
Ensure brevity in your answer.  0.13. What is the ratio of the Amount (in current US$) in 1973 in Low income to that in Middle income?
Provide a short and direct response. 0.13. What is the ratio of the Amount (in current US$) in 1970 in Low income to that in South Asia?
Provide a short and direct response. 0.26. What is the ratio of the Amount (in current US$) in 1971 in Low income to that in South Asia?
Your answer should be compact. 0.65. What is the ratio of the Amount (in current US$) of 1972 in Low income to that in South Asia?
Offer a terse response. 0.7. What is the ratio of the Amount (in current US$) of 1973 in Low income to that in South Asia?
Provide a short and direct response. 0.45. What is the ratio of the Amount (in current US$) of 1970 in Low income to that in Sub-Saharan Africa (developing only)?
Ensure brevity in your answer.  0.54. What is the ratio of the Amount (in current US$) of 1971 in Low income to that in Sub-Saharan Africa (developing only)?
Provide a succinct answer. 0.58. What is the ratio of the Amount (in current US$) in 1972 in Low income to that in Sub-Saharan Africa (developing only)?
Offer a very short reply. 0.52. What is the ratio of the Amount (in current US$) of 1973 in Low income to that in Sub-Saharan Africa (developing only)?
Ensure brevity in your answer.  0.8. What is the ratio of the Amount (in current US$) in 1970 in Lower middle income to that in Middle East & North Africa (developing only)?
Your answer should be very brief. 23.99. What is the ratio of the Amount (in current US$) in 1971 in Lower middle income to that in Middle East & North Africa (developing only)?
Offer a terse response. 11.49. What is the ratio of the Amount (in current US$) in 1972 in Lower middle income to that in Middle East & North Africa (developing only)?
Provide a succinct answer. 12.7. What is the ratio of the Amount (in current US$) of 1973 in Lower middle income to that in Middle East & North Africa (developing only)?
Make the answer very short. 9.48. What is the ratio of the Amount (in current US$) of 1970 in Lower middle income to that in Middle income?
Provide a succinct answer. 0.41. What is the ratio of the Amount (in current US$) in 1971 in Lower middle income to that in Middle income?
Your answer should be compact. 0.41. What is the ratio of the Amount (in current US$) in 1972 in Lower middle income to that in Middle income?
Offer a terse response. 0.42. What is the ratio of the Amount (in current US$) in 1973 in Lower middle income to that in Middle income?
Ensure brevity in your answer.  0.47. What is the ratio of the Amount (in current US$) in 1970 in Lower middle income to that in South Asia?
Your answer should be very brief. 1.65. What is the ratio of the Amount (in current US$) in 1971 in Lower middle income to that in South Asia?
Ensure brevity in your answer.  2.56. What is the ratio of the Amount (in current US$) in 1972 in Lower middle income to that in South Asia?
Give a very brief answer. 2.37. What is the ratio of the Amount (in current US$) of 1973 in Lower middle income to that in South Asia?
Your answer should be compact. 1.6. What is the ratio of the Amount (in current US$) in 1970 in Lower middle income to that in Sub-Saharan Africa (developing only)?
Make the answer very short. 3.35. What is the ratio of the Amount (in current US$) in 1971 in Lower middle income to that in Sub-Saharan Africa (developing only)?
Your response must be concise. 2.28. What is the ratio of the Amount (in current US$) in 1972 in Lower middle income to that in Sub-Saharan Africa (developing only)?
Your answer should be compact. 1.75. What is the ratio of the Amount (in current US$) of 1973 in Lower middle income to that in Sub-Saharan Africa (developing only)?
Provide a short and direct response. 2.84. What is the ratio of the Amount (in current US$) of 1970 in Middle East & North Africa (developing only) to that in Middle income?
Your answer should be compact. 0.02. What is the ratio of the Amount (in current US$) of 1971 in Middle East & North Africa (developing only) to that in Middle income?
Make the answer very short. 0.04. What is the ratio of the Amount (in current US$) of 1972 in Middle East & North Africa (developing only) to that in Middle income?
Offer a very short reply. 0.03. What is the ratio of the Amount (in current US$) in 1973 in Middle East & North Africa (developing only) to that in Middle income?
Offer a very short reply. 0.05. What is the ratio of the Amount (in current US$) of 1970 in Middle East & North Africa (developing only) to that in South Asia?
Provide a succinct answer. 0.07. What is the ratio of the Amount (in current US$) of 1971 in Middle East & North Africa (developing only) to that in South Asia?
Your answer should be very brief. 0.22. What is the ratio of the Amount (in current US$) of 1972 in Middle East & North Africa (developing only) to that in South Asia?
Your answer should be compact. 0.19. What is the ratio of the Amount (in current US$) of 1973 in Middle East & North Africa (developing only) to that in South Asia?
Provide a succinct answer. 0.17. What is the ratio of the Amount (in current US$) in 1970 in Middle East & North Africa (developing only) to that in Sub-Saharan Africa (developing only)?
Make the answer very short. 0.14. What is the ratio of the Amount (in current US$) of 1971 in Middle East & North Africa (developing only) to that in Sub-Saharan Africa (developing only)?
Give a very brief answer. 0.2. What is the ratio of the Amount (in current US$) in 1972 in Middle East & North Africa (developing only) to that in Sub-Saharan Africa (developing only)?
Give a very brief answer. 0.14. What is the ratio of the Amount (in current US$) in 1973 in Middle East & North Africa (developing only) to that in Sub-Saharan Africa (developing only)?
Offer a very short reply. 0.3. What is the ratio of the Amount (in current US$) in 1970 in Middle income to that in South Asia?
Make the answer very short. 4.01. What is the ratio of the Amount (in current US$) in 1971 in Middle income to that in South Asia?
Make the answer very short. 6.23. What is the ratio of the Amount (in current US$) in 1972 in Middle income to that in South Asia?
Make the answer very short. 5.62. What is the ratio of the Amount (in current US$) of 1973 in Middle income to that in South Asia?
Your response must be concise. 3.4. What is the ratio of the Amount (in current US$) in 1970 in Middle income to that in Sub-Saharan Africa (developing only)?
Ensure brevity in your answer.  8.13. What is the ratio of the Amount (in current US$) in 1971 in Middle income to that in Sub-Saharan Africa (developing only)?
Your response must be concise. 5.56. What is the ratio of the Amount (in current US$) of 1972 in Middle income to that in Sub-Saharan Africa (developing only)?
Offer a terse response. 4.15. What is the ratio of the Amount (in current US$) of 1973 in Middle income to that in Sub-Saharan Africa (developing only)?
Provide a succinct answer. 6.02. What is the ratio of the Amount (in current US$) of 1970 in South Asia to that in Sub-Saharan Africa (developing only)?
Your answer should be very brief. 2.03. What is the ratio of the Amount (in current US$) in 1971 in South Asia to that in Sub-Saharan Africa (developing only)?
Offer a very short reply. 0.89. What is the ratio of the Amount (in current US$) in 1972 in South Asia to that in Sub-Saharan Africa (developing only)?
Make the answer very short. 0.74. What is the ratio of the Amount (in current US$) in 1973 in South Asia to that in Sub-Saharan Africa (developing only)?
Provide a succinct answer. 1.77. What is the difference between the highest and the second highest Amount (in current US$) of 1970?
Give a very brief answer. 5.59e+08. What is the difference between the highest and the second highest Amount (in current US$) of 1971?
Offer a terse response. 5.57e+08. What is the difference between the highest and the second highest Amount (in current US$) of 1972?
Offer a terse response. 6.59e+08. What is the difference between the highest and the second highest Amount (in current US$) in 1973?
Your answer should be very brief. 7.93e+08. What is the difference between the highest and the lowest Amount (in current US$) of 1970?
Offer a very short reply. 9.35e+08. What is the difference between the highest and the lowest Amount (in current US$) of 1971?
Offer a terse response. 9.10e+08. What is the difference between the highest and the lowest Amount (in current US$) in 1972?
Offer a terse response. 1.10e+09. What is the difference between the highest and the lowest Amount (in current US$) of 1973?
Offer a terse response. 1.42e+09. 